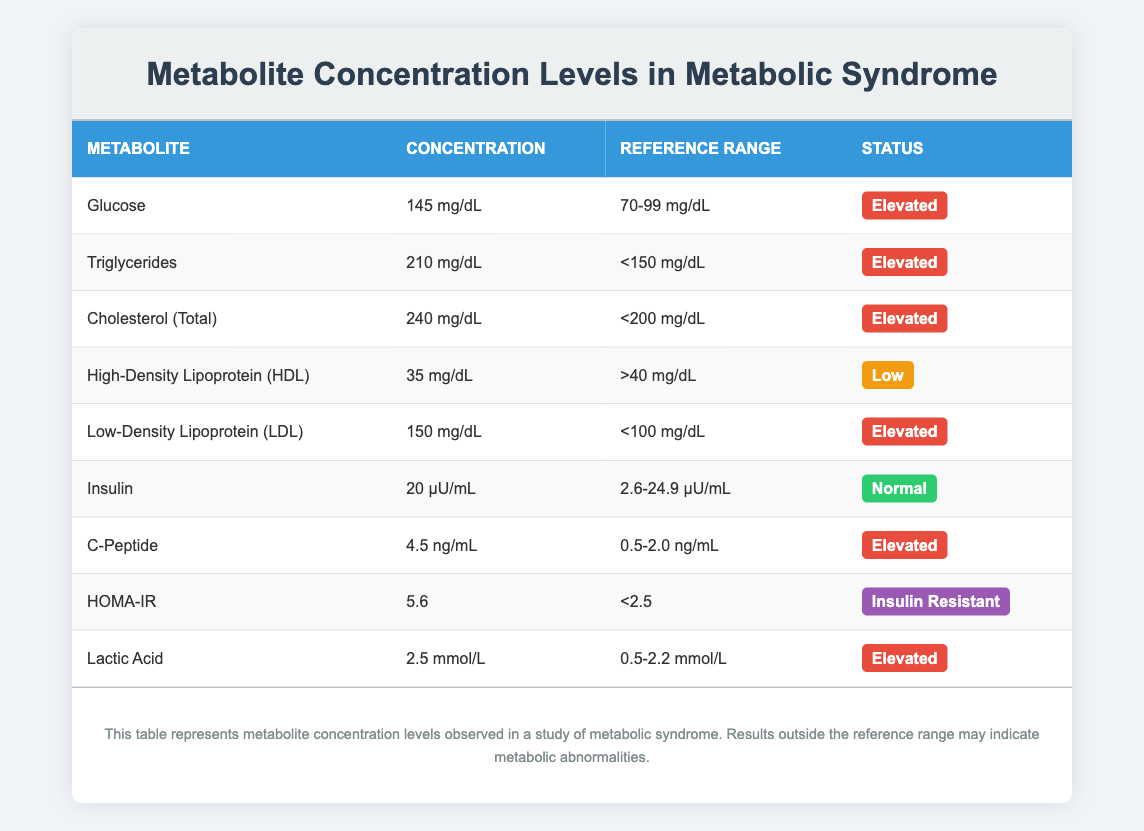What is the concentration of Glucose? The table lists the concentration of Glucose as 145 mg/dL.
Answer: 145 mg/dL Which metabolite has a status marked as "Low"? The table shows that High-Density Lipoprotein (HDL) has a concentration of 35 mg/dL and is marked as "Low."
Answer: High-Density Lipoprotein (HDL) Is the C-Peptide concentration elevated? The concentration of C-Peptide is 4.5 ng/mL, which is above the reference range of 0.5-2.0 ng/mL, thus it is categorized as "Elevated."
Answer: Yes What are the total number of elevated metabolites listed in the table? There are five metabolites classified as "Elevated": Glucose, Triglycerides, Cholesterol (Total), Low-Density Lipoprotein (LDL), C-Peptide, and Lactic Acid. Counting these gives a total of 6 elevated metabolites.
Answer: 6 What is the average concentration of the elevated metabolites? To calculate the average, we first list their concentrations: Glucose (145 mg/dL), Triglycerides (210 mg/dL), Cholesterol (Total) (240 mg/dL), Low-Density Lipoprotein (LDL) (150 mg/dL), C-Peptide (4.5 ng/mL), and Lactic Acid (2.5 mmol/L). Summing the mg/dL values: (145 + 210 + 240 + 150 = 745), and then take the average of these four by dividing by 4, which equals 186.25. So this is only for mg/dL values.
Answer: 186.25 mg/dL Which metabolite has the highest concentration? The table indicates that Cholesterol (Total) has the highest concentration at 240 mg/dL compared to other listed metabolites.
Answer: Cholesterol (Total) 